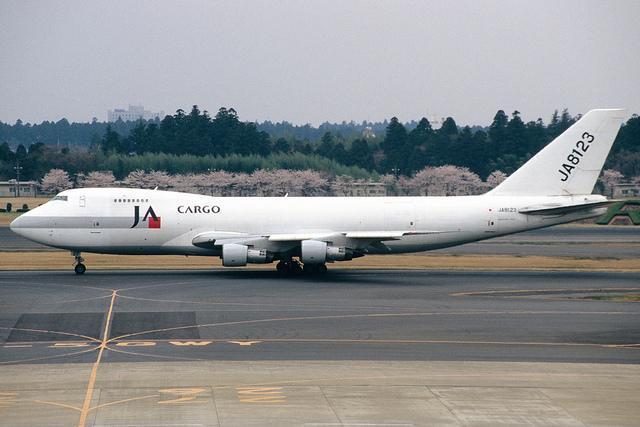How many planes are in the picture?
Give a very brief answer. 1. 